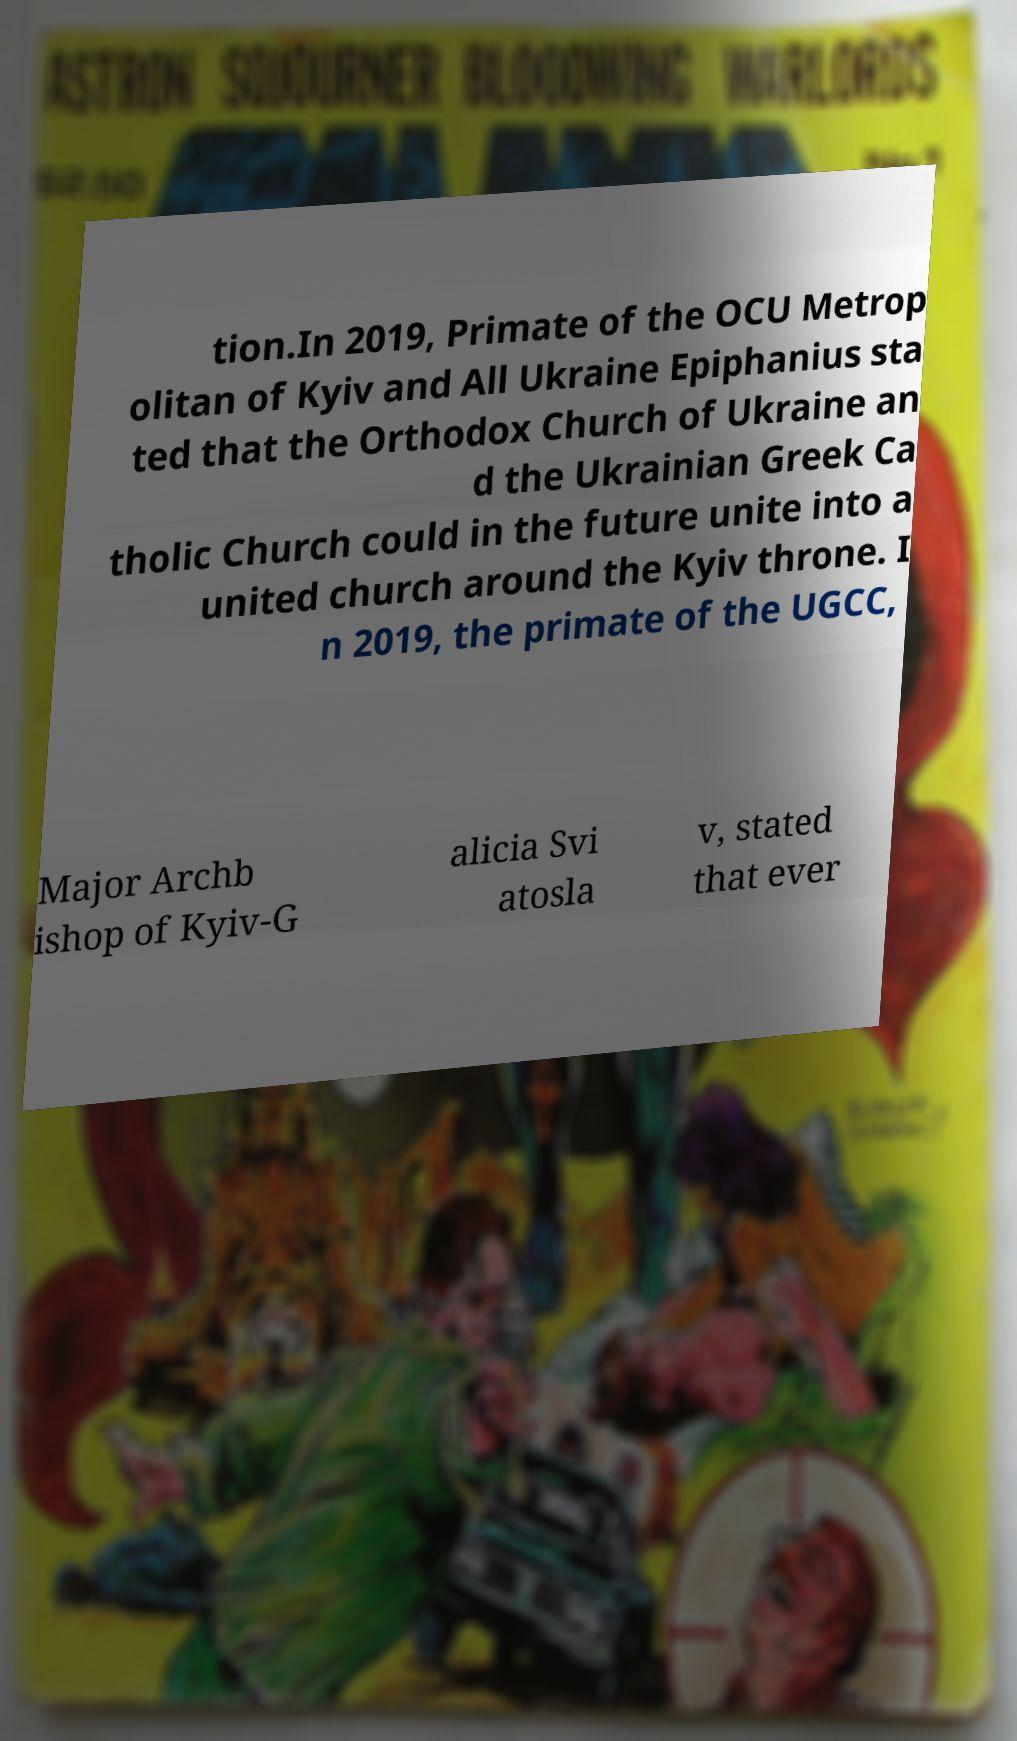Could you assist in decoding the text presented in this image and type it out clearly? tion.In 2019, Primate of the OCU Metrop olitan of Kyiv and All Ukraine Epiphanius sta ted that the Orthodox Church of Ukraine an d the Ukrainian Greek Ca tholic Church could in the future unite into a united church around the Kyiv throne. I n 2019, the primate of the UGCC, Major Archb ishop of Kyiv-G alicia Svi atosla v, stated that ever 